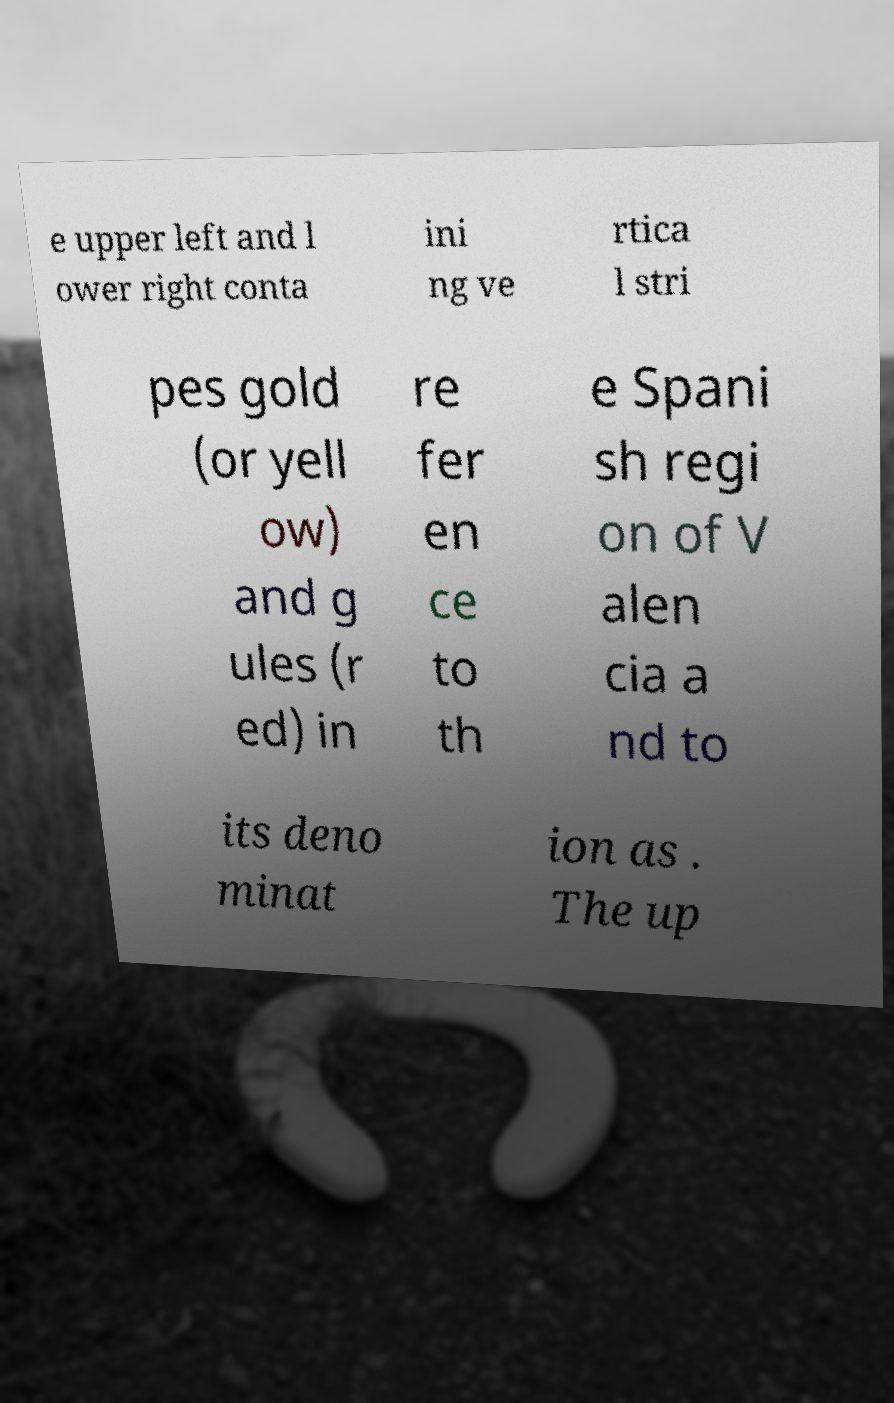There's text embedded in this image that I need extracted. Can you transcribe it verbatim? e upper left and l ower right conta ini ng ve rtica l stri pes gold (or yell ow) and g ules (r ed) in re fer en ce to th e Spani sh regi on of V alen cia a nd to its deno minat ion as . The up 